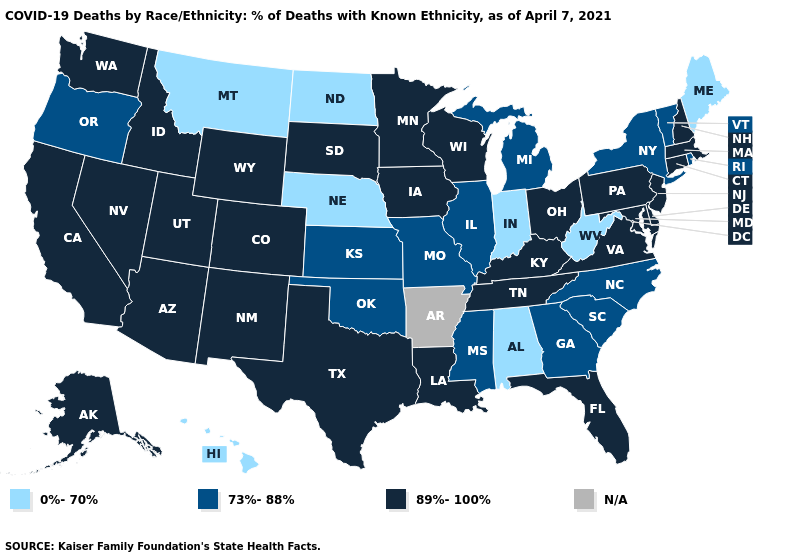What is the value of New Mexico?
Be succinct. 89%-100%. Name the states that have a value in the range 0%-70%?
Short answer required. Alabama, Hawaii, Indiana, Maine, Montana, Nebraska, North Dakota, West Virginia. What is the lowest value in states that border South Carolina?
Answer briefly. 73%-88%. Is the legend a continuous bar?
Write a very short answer. No. What is the highest value in the Northeast ?
Concise answer only. 89%-100%. Name the states that have a value in the range 73%-88%?
Short answer required. Georgia, Illinois, Kansas, Michigan, Mississippi, Missouri, New York, North Carolina, Oklahoma, Oregon, Rhode Island, South Carolina, Vermont. What is the value of South Carolina?
Concise answer only. 73%-88%. Among the states that border Pennsylvania , does West Virginia have the highest value?
Short answer required. No. What is the lowest value in the USA?
Keep it brief. 0%-70%. What is the value of Connecticut?
Short answer required. 89%-100%. Does the first symbol in the legend represent the smallest category?
Write a very short answer. Yes. What is the value of Missouri?
Concise answer only. 73%-88%. What is the value of Montana?
Quick response, please. 0%-70%. Name the states that have a value in the range N/A?
Write a very short answer. Arkansas. What is the highest value in the USA?
Quick response, please. 89%-100%. 